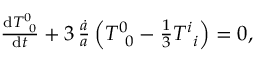Convert formula to latex. <formula><loc_0><loc_0><loc_500><loc_500>\begin{array} { r } { \frac { d T _ { \, 0 } ^ { 0 } } { d t } + 3 \, \frac { \dot { a } } { a } \left ( T _ { \, 0 } ^ { 0 } - \frac { 1 } { 3 } T _ { \, i } ^ { i } \right ) = 0 , } \end{array}</formula> 